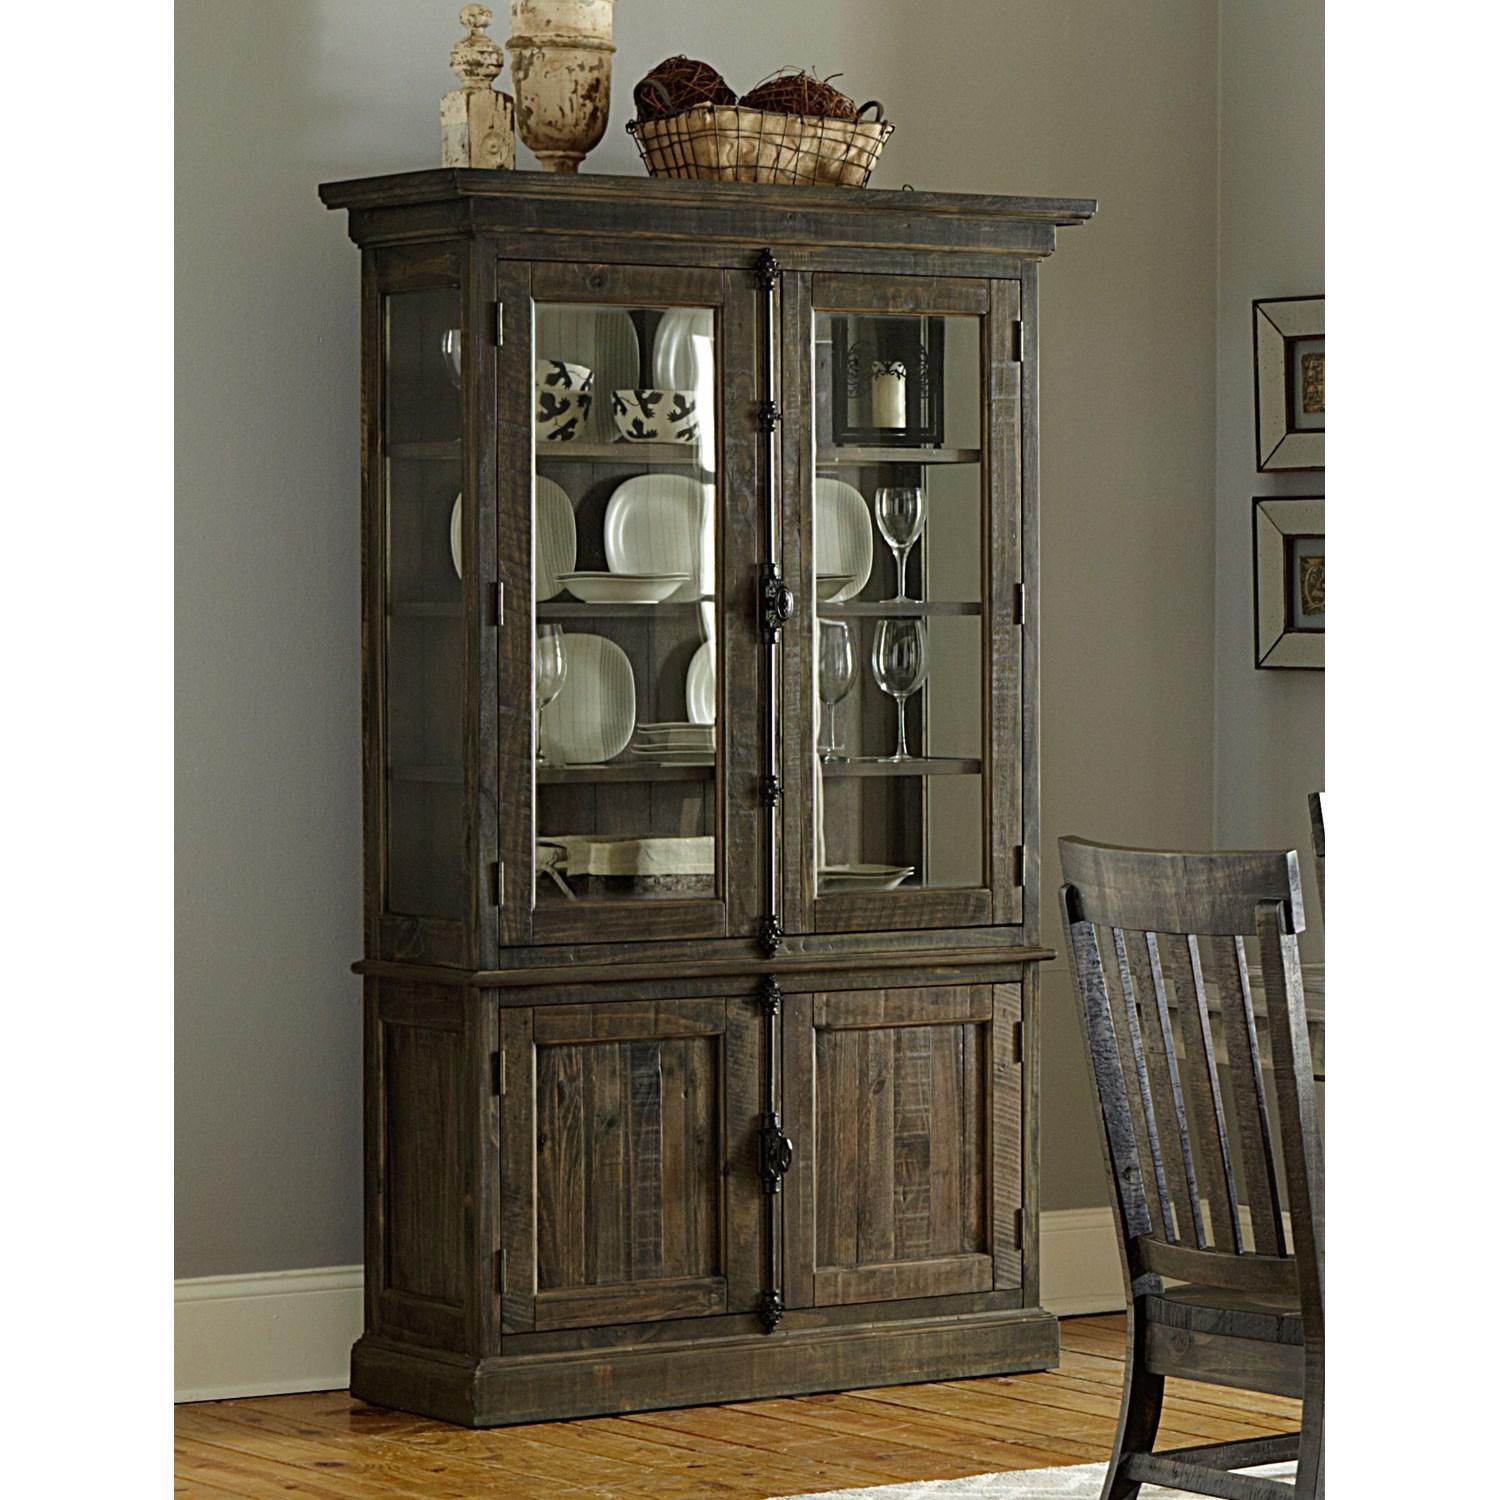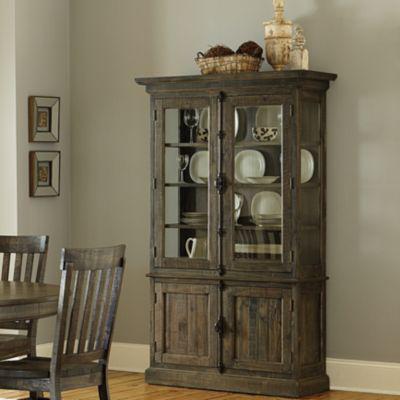The first image is the image on the left, the second image is the image on the right. Evaluate the accuracy of this statement regarding the images: "There is a combined total of three chairs between the two images.". Is it true? Answer yes or no. Yes. The first image is the image on the left, the second image is the image on the right. Considering the images on both sides, is "There is basket of dark objects atop the china cabinet in the image on the right." valid? Answer yes or no. Yes. 